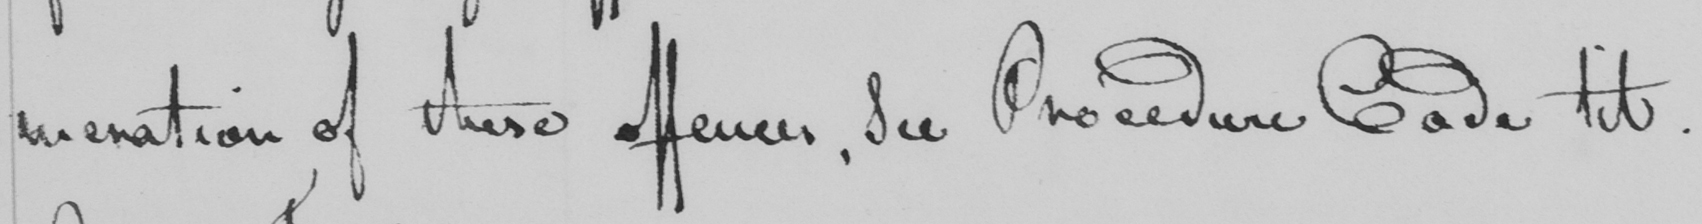Transcribe the text shown in this historical manuscript line. meration of these offences, See Procedure Code tit. 